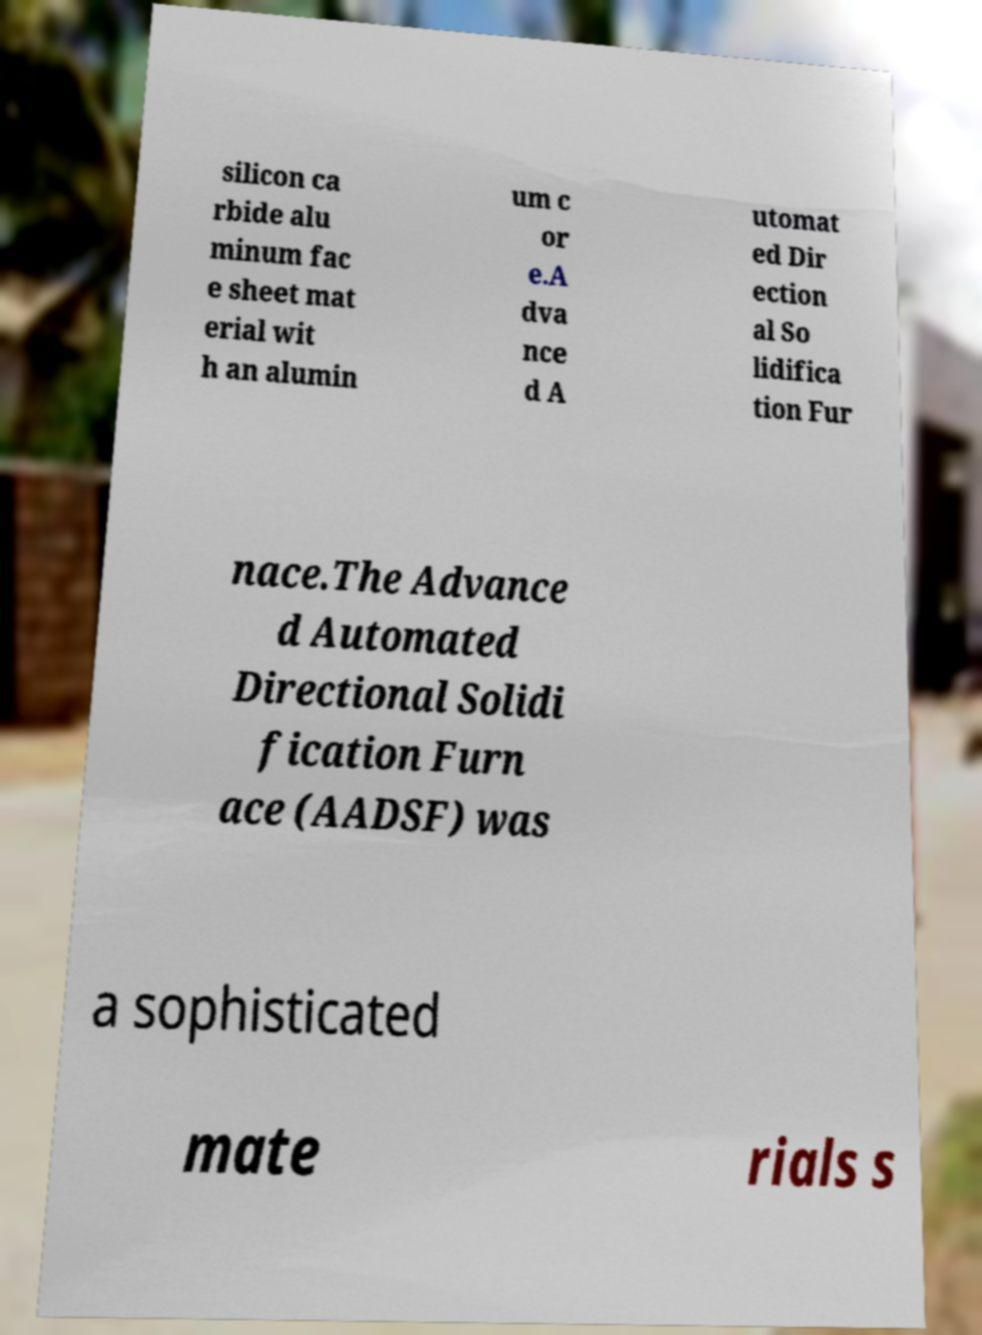For documentation purposes, I need the text within this image transcribed. Could you provide that? silicon ca rbide alu minum fac e sheet mat erial wit h an alumin um c or e.A dva nce d A utomat ed Dir ection al So lidifica tion Fur nace.The Advance d Automated Directional Solidi fication Furn ace (AADSF) was a sophisticated mate rials s 